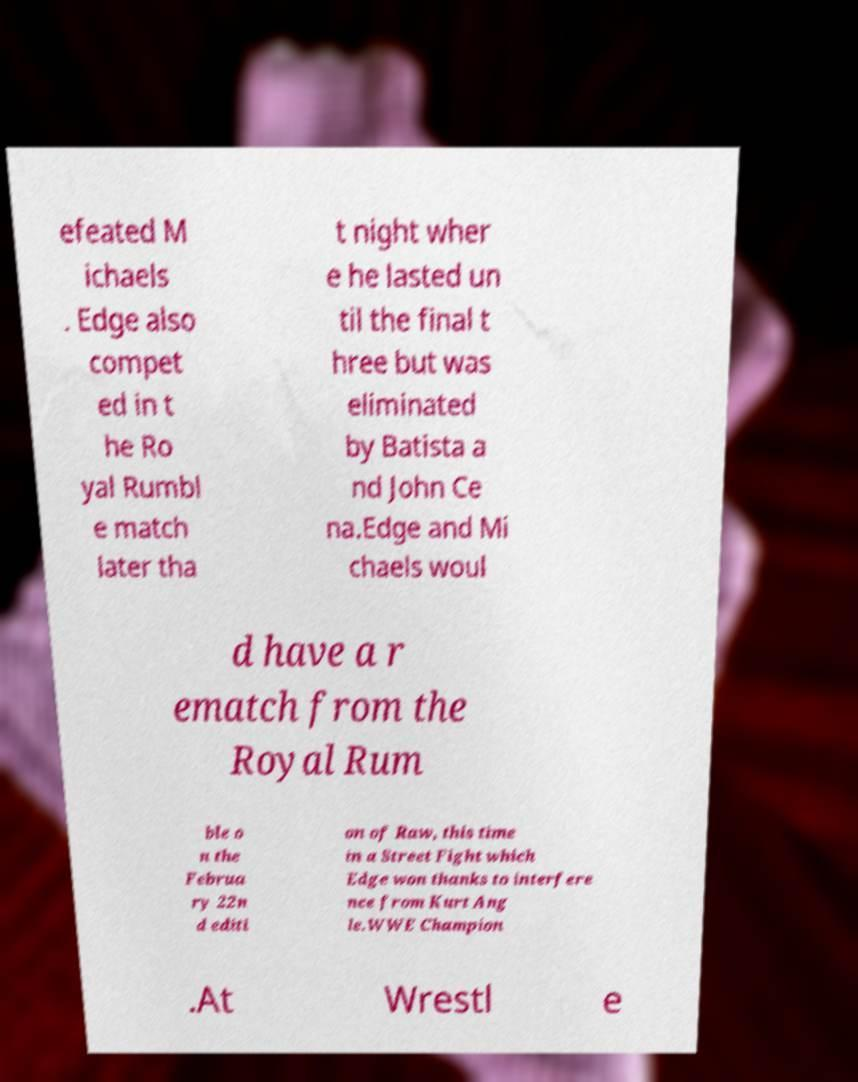What messages or text are displayed in this image? I need them in a readable, typed format. efeated M ichaels . Edge also compet ed in t he Ro yal Rumbl e match later tha t night wher e he lasted un til the final t hree but was eliminated by Batista a nd John Ce na.Edge and Mi chaels woul d have a r ematch from the Royal Rum ble o n the Februa ry 22n d editi on of Raw, this time in a Street Fight which Edge won thanks to interfere nce from Kurt Ang le.WWE Champion .At Wrestl e 